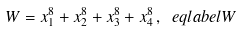Convert formula to latex. <formula><loc_0><loc_0><loc_500><loc_500>W = x _ { 1 } ^ { 8 } + x _ { 2 } ^ { 8 } + x _ { 3 } ^ { 8 } + x _ { 4 } ^ { 8 } \, , \ e q l a b e l { W }</formula> 